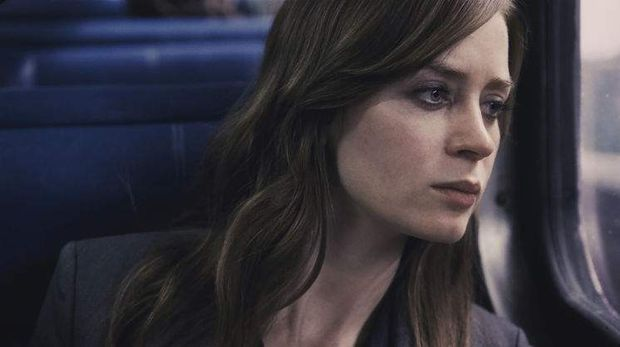Could this scene be symbolic of her journey in the movie? Absolutely, the train setting often symbolizes a journey both literal and metaphorical. In this context, it likely represents her personal journey towards discovering truth and confronting her realities, mirroring the emotional rollercoaster she experiences throughout the film. 